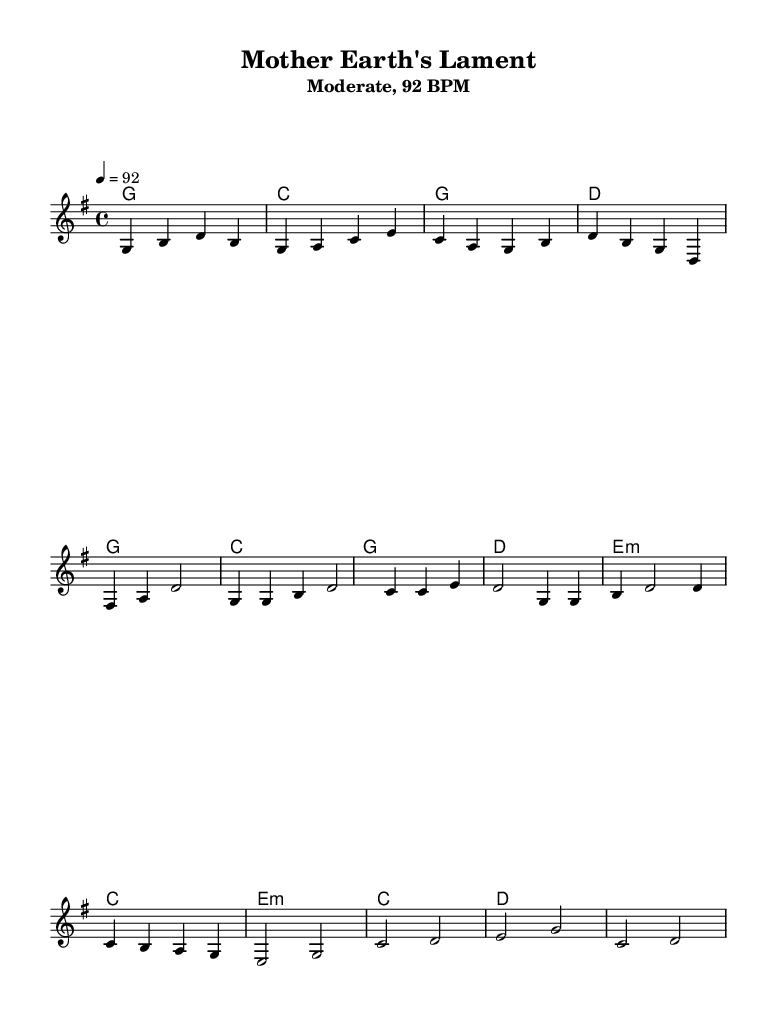What is the key signature of this music? The key signature is G major, which has one sharp (F sharp).
Answer: G major What is the time signature of this music? The time signature is 4/4, indicating that there are four beats in each measure.
Answer: 4/4 What is the tempo marking of this piece? The tempo marking is 92 BPM, indicating the piece should be played at a moderate speed.
Answer: 92 BPM How many measures are in the verse section? The verse section consists of four measures, as identified by counting the groups of bars in the melody part.
Answer: 4 measures What type of chords are predominantly used in the chorus? The chords in the chorus are primarily major chords, which contribute to the uplifting character typical of country music.
Answer: Major chords Which musical element reflects a nature-inspired theme in this piece? The title "Mother Earth's Lament" suggests a connection to nature and urgency, while the melodic and harmonic phrases evoke a sense of longing and beauty.
Answer: Title How does the bridge section differ harmonically from the verse? The bridge introduces minor chords (e minor), creating contrast with the predominantly major harmonies in the verse, enhancing the emotional depth.
Answer: Minor chords 